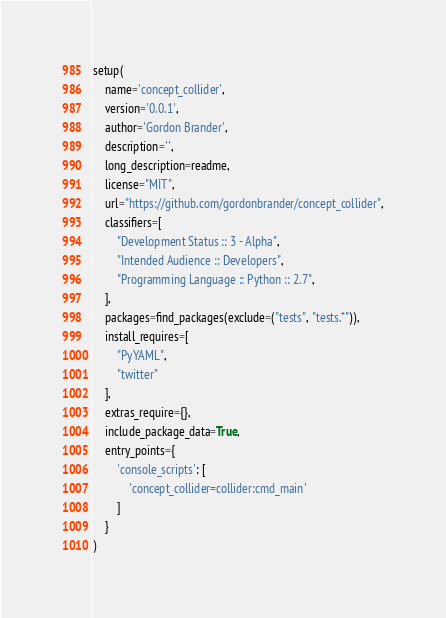Convert code to text. <code><loc_0><loc_0><loc_500><loc_500><_Python_>setup(
    name='concept_collider',
    version='0.0.1',
    author='Gordon Brander',
    description='',
    long_description=readme,
    license="MIT",
    url="https://github.com/gordonbrander/concept_collider",
    classifiers=[
        "Development Status :: 3 - Alpha",
        "Intended Audience :: Developers",
        "Programming Language :: Python :: 2.7",
    ],
    packages=find_packages(exclude=("tests", "tests.*")),
    install_requires=[
        "PyYAML",
        "twitter"
    ],
    extras_require={},
    include_package_data=True,
    entry_points={
        'console_scripts': [
            'concept_collider=collider:cmd_main'
        ]
    }
)
</code> 